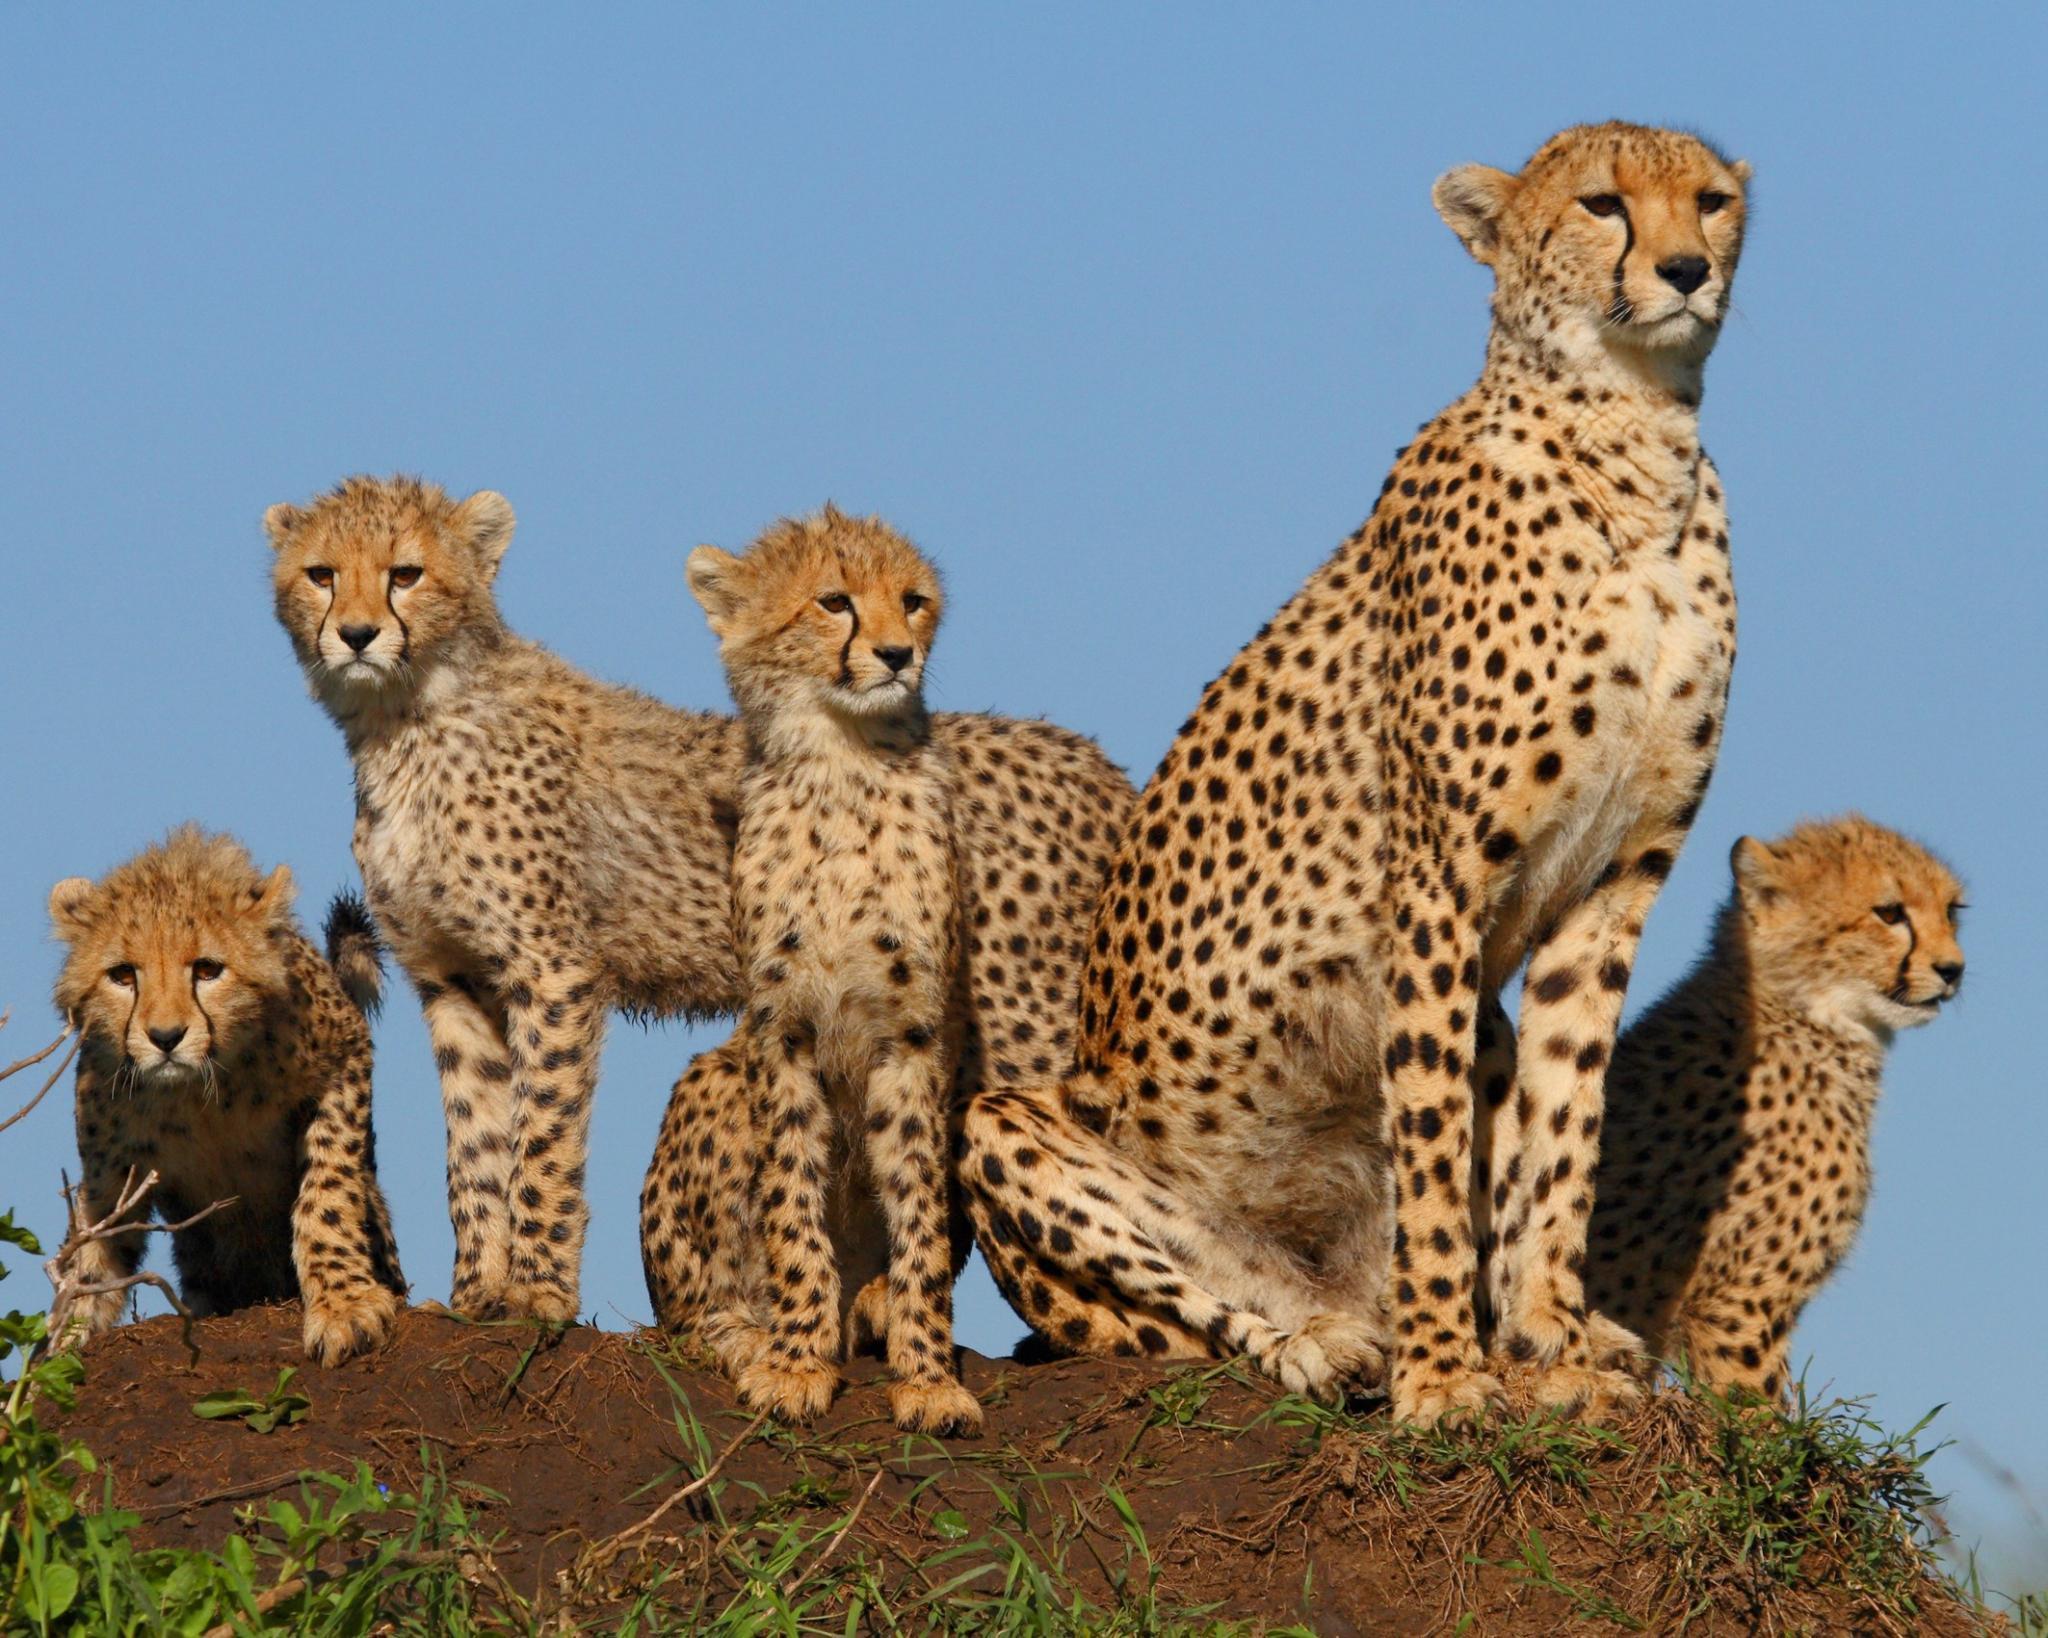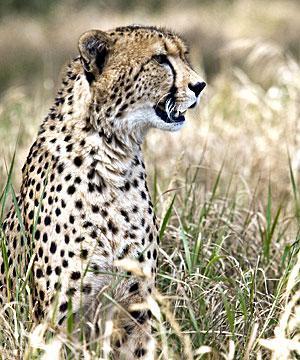The first image is the image on the left, the second image is the image on the right. Examine the images to the left and right. Is the description "There are no more than 2 cheetas in the right image." accurate? Answer yes or no. Yes. The first image is the image on the left, the second image is the image on the right. Analyze the images presented: Is the assertion "There are no more than two cheetahs in the right image." valid? Answer yes or no. Yes. 